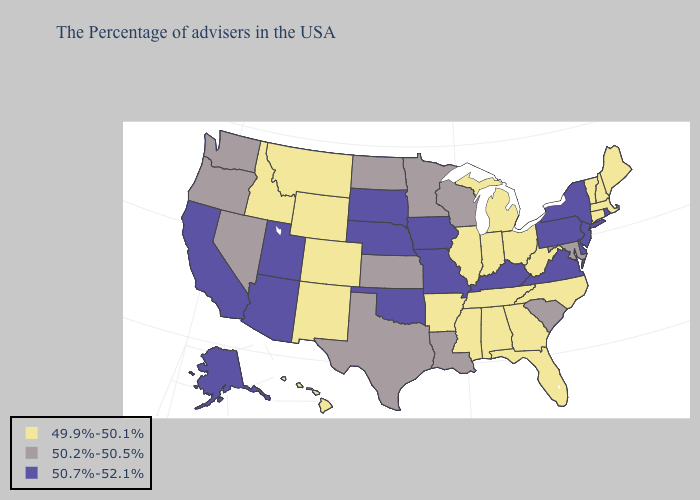Name the states that have a value in the range 50.7%-52.1%?
Be succinct. Rhode Island, New York, New Jersey, Delaware, Pennsylvania, Virginia, Kentucky, Missouri, Iowa, Nebraska, Oklahoma, South Dakota, Utah, Arizona, California, Alaska. How many symbols are there in the legend?
Write a very short answer. 3. What is the lowest value in states that border North Dakota?
Write a very short answer. 49.9%-50.1%. Does the first symbol in the legend represent the smallest category?
Short answer required. Yes. Which states hav the highest value in the Northeast?
Be succinct. Rhode Island, New York, New Jersey, Pennsylvania. Does Texas have the lowest value in the USA?
Give a very brief answer. No. Name the states that have a value in the range 49.9%-50.1%?
Quick response, please. Maine, Massachusetts, New Hampshire, Vermont, Connecticut, North Carolina, West Virginia, Ohio, Florida, Georgia, Michigan, Indiana, Alabama, Tennessee, Illinois, Mississippi, Arkansas, Wyoming, Colorado, New Mexico, Montana, Idaho, Hawaii. Is the legend a continuous bar?
Write a very short answer. No. Name the states that have a value in the range 49.9%-50.1%?
Answer briefly. Maine, Massachusetts, New Hampshire, Vermont, Connecticut, North Carolina, West Virginia, Ohio, Florida, Georgia, Michigan, Indiana, Alabama, Tennessee, Illinois, Mississippi, Arkansas, Wyoming, Colorado, New Mexico, Montana, Idaho, Hawaii. What is the lowest value in the USA?
Be succinct. 49.9%-50.1%. Does the first symbol in the legend represent the smallest category?
Keep it brief. Yes. Does Alaska have the same value as Delaware?
Answer briefly. Yes. What is the value of Nebraska?
Give a very brief answer. 50.7%-52.1%. What is the lowest value in states that border Wisconsin?
Keep it brief. 49.9%-50.1%. Does the first symbol in the legend represent the smallest category?
Keep it brief. Yes. 